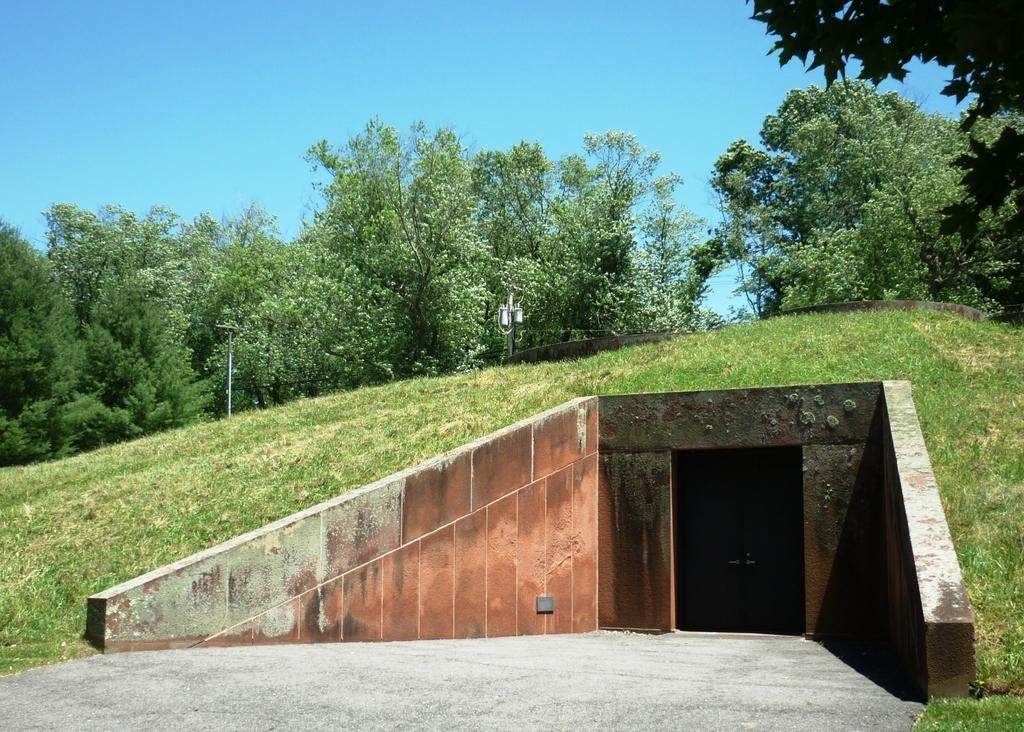Please provide a concise description of this image. In this image we can see a tunnel and there is grass. In the background there are trees and sky. 